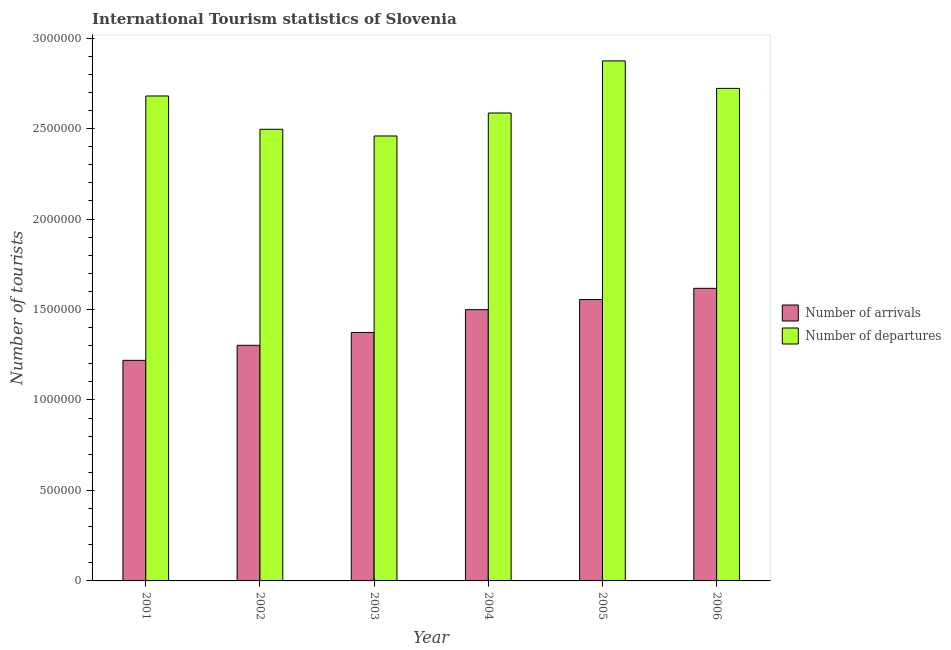How many groups of bars are there?
Provide a succinct answer. 6. Are the number of bars per tick equal to the number of legend labels?
Offer a very short reply. Yes. Are the number of bars on each tick of the X-axis equal?
Your answer should be very brief. Yes. How many bars are there on the 2nd tick from the left?
Give a very brief answer. 2. What is the number of tourist departures in 2001?
Provide a succinct answer. 2.68e+06. Across all years, what is the maximum number of tourist departures?
Your answer should be compact. 2.87e+06. Across all years, what is the minimum number of tourist departures?
Make the answer very short. 2.46e+06. What is the total number of tourist departures in the graph?
Provide a short and direct response. 1.58e+07. What is the difference between the number of tourist arrivals in 2001 and that in 2004?
Provide a succinct answer. -2.80e+05. What is the difference between the number of tourist arrivals in 2003 and the number of tourist departures in 2005?
Provide a short and direct response. -1.82e+05. What is the average number of tourist departures per year?
Your response must be concise. 2.64e+06. In how many years, is the number of tourist arrivals greater than 1400000?
Your response must be concise. 3. What is the ratio of the number of tourist arrivals in 2003 to that in 2005?
Give a very brief answer. 0.88. What is the difference between the highest and the second highest number of tourist arrivals?
Your answer should be very brief. 6.20e+04. What is the difference between the highest and the lowest number of tourist departures?
Ensure brevity in your answer.  4.15e+05. Is the sum of the number of tourist departures in 2003 and 2006 greater than the maximum number of tourist arrivals across all years?
Provide a succinct answer. Yes. What does the 1st bar from the left in 2006 represents?
Offer a very short reply. Number of arrivals. What does the 1st bar from the right in 2003 represents?
Provide a short and direct response. Number of departures. How many years are there in the graph?
Keep it short and to the point. 6. Are the values on the major ticks of Y-axis written in scientific E-notation?
Keep it short and to the point. No. Does the graph contain grids?
Give a very brief answer. No. How are the legend labels stacked?
Keep it short and to the point. Vertical. What is the title of the graph?
Your response must be concise. International Tourism statistics of Slovenia. What is the label or title of the X-axis?
Give a very brief answer. Year. What is the label or title of the Y-axis?
Keep it short and to the point. Number of tourists. What is the Number of tourists of Number of arrivals in 2001?
Give a very brief answer. 1.22e+06. What is the Number of tourists of Number of departures in 2001?
Provide a succinct answer. 2.68e+06. What is the Number of tourists of Number of arrivals in 2002?
Give a very brief answer. 1.30e+06. What is the Number of tourists in Number of departures in 2002?
Your answer should be very brief. 2.50e+06. What is the Number of tourists of Number of arrivals in 2003?
Ensure brevity in your answer.  1.37e+06. What is the Number of tourists of Number of departures in 2003?
Provide a short and direct response. 2.46e+06. What is the Number of tourists of Number of arrivals in 2004?
Provide a short and direct response. 1.50e+06. What is the Number of tourists in Number of departures in 2004?
Keep it short and to the point. 2.59e+06. What is the Number of tourists in Number of arrivals in 2005?
Offer a very short reply. 1.56e+06. What is the Number of tourists in Number of departures in 2005?
Your answer should be compact. 2.87e+06. What is the Number of tourists in Number of arrivals in 2006?
Ensure brevity in your answer.  1.62e+06. What is the Number of tourists of Number of departures in 2006?
Offer a terse response. 2.72e+06. Across all years, what is the maximum Number of tourists of Number of arrivals?
Your response must be concise. 1.62e+06. Across all years, what is the maximum Number of tourists of Number of departures?
Provide a short and direct response. 2.87e+06. Across all years, what is the minimum Number of tourists of Number of arrivals?
Offer a terse response. 1.22e+06. Across all years, what is the minimum Number of tourists in Number of departures?
Ensure brevity in your answer.  2.46e+06. What is the total Number of tourists in Number of arrivals in the graph?
Your response must be concise. 8.56e+06. What is the total Number of tourists in Number of departures in the graph?
Your response must be concise. 1.58e+07. What is the difference between the Number of tourists in Number of arrivals in 2001 and that in 2002?
Make the answer very short. -8.30e+04. What is the difference between the Number of tourists in Number of departures in 2001 and that in 2002?
Your answer should be compact. 1.84e+05. What is the difference between the Number of tourists in Number of arrivals in 2001 and that in 2003?
Ensure brevity in your answer.  -1.54e+05. What is the difference between the Number of tourists in Number of departures in 2001 and that in 2003?
Provide a succinct answer. 2.21e+05. What is the difference between the Number of tourists of Number of arrivals in 2001 and that in 2004?
Provide a succinct answer. -2.80e+05. What is the difference between the Number of tourists of Number of departures in 2001 and that in 2004?
Your answer should be compact. 9.40e+04. What is the difference between the Number of tourists in Number of arrivals in 2001 and that in 2005?
Offer a terse response. -3.36e+05. What is the difference between the Number of tourists in Number of departures in 2001 and that in 2005?
Offer a very short reply. -1.94e+05. What is the difference between the Number of tourists of Number of arrivals in 2001 and that in 2006?
Provide a succinct answer. -3.98e+05. What is the difference between the Number of tourists of Number of departures in 2001 and that in 2006?
Offer a terse response. -4.20e+04. What is the difference between the Number of tourists in Number of arrivals in 2002 and that in 2003?
Your answer should be compact. -7.10e+04. What is the difference between the Number of tourists of Number of departures in 2002 and that in 2003?
Give a very brief answer. 3.70e+04. What is the difference between the Number of tourists in Number of arrivals in 2002 and that in 2004?
Give a very brief answer. -1.97e+05. What is the difference between the Number of tourists in Number of departures in 2002 and that in 2004?
Your answer should be very brief. -9.00e+04. What is the difference between the Number of tourists in Number of arrivals in 2002 and that in 2005?
Your response must be concise. -2.53e+05. What is the difference between the Number of tourists of Number of departures in 2002 and that in 2005?
Keep it short and to the point. -3.78e+05. What is the difference between the Number of tourists in Number of arrivals in 2002 and that in 2006?
Offer a terse response. -3.15e+05. What is the difference between the Number of tourists of Number of departures in 2002 and that in 2006?
Offer a very short reply. -2.26e+05. What is the difference between the Number of tourists in Number of arrivals in 2003 and that in 2004?
Your answer should be very brief. -1.26e+05. What is the difference between the Number of tourists in Number of departures in 2003 and that in 2004?
Ensure brevity in your answer.  -1.27e+05. What is the difference between the Number of tourists in Number of arrivals in 2003 and that in 2005?
Make the answer very short. -1.82e+05. What is the difference between the Number of tourists of Number of departures in 2003 and that in 2005?
Provide a short and direct response. -4.15e+05. What is the difference between the Number of tourists in Number of arrivals in 2003 and that in 2006?
Your response must be concise. -2.44e+05. What is the difference between the Number of tourists of Number of departures in 2003 and that in 2006?
Ensure brevity in your answer.  -2.63e+05. What is the difference between the Number of tourists in Number of arrivals in 2004 and that in 2005?
Your answer should be compact. -5.60e+04. What is the difference between the Number of tourists in Number of departures in 2004 and that in 2005?
Your answer should be compact. -2.88e+05. What is the difference between the Number of tourists of Number of arrivals in 2004 and that in 2006?
Ensure brevity in your answer.  -1.18e+05. What is the difference between the Number of tourists of Number of departures in 2004 and that in 2006?
Ensure brevity in your answer.  -1.36e+05. What is the difference between the Number of tourists of Number of arrivals in 2005 and that in 2006?
Ensure brevity in your answer.  -6.20e+04. What is the difference between the Number of tourists in Number of departures in 2005 and that in 2006?
Give a very brief answer. 1.52e+05. What is the difference between the Number of tourists of Number of arrivals in 2001 and the Number of tourists of Number of departures in 2002?
Offer a terse response. -1.28e+06. What is the difference between the Number of tourists of Number of arrivals in 2001 and the Number of tourists of Number of departures in 2003?
Offer a terse response. -1.24e+06. What is the difference between the Number of tourists of Number of arrivals in 2001 and the Number of tourists of Number of departures in 2004?
Provide a succinct answer. -1.37e+06. What is the difference between the Number of tourists of Number of arrivals in 2001 and the Number of tourists of Number of departures in 2005?
Offer a terse response. -1.66e+06. What is the difference between the Number of tourists in Number of arrivals in 2001 and the Number of tourists in Number of departures in 2006?
Offer a very short reply. -1.50e+06. What is the difference between the Number of tourists in Number of arrivals in 2002 and the Number of tourists in Number of departures in 2003?
Keep it short and to the point. -1.16e+06. What is the difference between the Number of tourists of Number of arrivals in 2002 and the Number of tourists of Number of departures in 2004?
Your answer should be compact. -1.28e+06. What is the difference between the Number of tourists of Number of arrivals in 2002 and the Number of tourists of Number of departures in 2005?
Provide a succinct answer. -1.57e+06. What is the difference between the Number of tourists in Number of arrivals in 2002 and the Number of tourists in Number of departures in 2006?
Offer a terse response. -1.42e+06. What is the difference between the Number of tourists of Number of arrivals in 2003 and the Number of tourists of Number of departures in 2004?
Provide a short and direct response. -1.21e+06. What is the difference between the Number of tourists of Number of arrivals in 2003 and the Number of tourists of Number of departures in 2005?
Ensure brevity in your answer.  -1.50e+06. What is the difference between the Number of tourists of Number of arrivals in 2003 and the Number of tourists of Number of departures in 2006?
Your response must be concise. -1.35e+06. What is the difference between the Number of tourists in Number of arrivals in 2004 and the Number of tourists in Number of departures in 2005?
Make the answer very short. -1.38e+06. What is the difference between the Number of tourists of Number of arrivals in 2004 and the Number of tourists of Number of departures in 2006?
Your response must be concise. -1.22e+06. What is the difference between the Number of tourists of Number of arrivals in 2005 and the Number of tourists of Number of departures in 2006?
Offer a terse response. -1.17e+06. What is the average Number of tourists in Number of arrivals per year?
Keep it short and to the point. 1.43e+06. What is the average Number of tourists of Number of departures per year?
Offer a very short reply. 2.64e+06. In the year 2001, what is the difference between the Number of tourists in Number of arrivals and Number of tourists in Number of departures?
Your answer should be very brief. -1.46e+06. In the year 2002, what is the difference between the Number of tourists of Number of arrivals and Number of tourists of Number of departures?
Your response must be concise. -1.19e+06. In the year 2003, what is the difference between the Number of tourists in Number of arrivals and Number of tourists in Number of departures?
Your response must be concise. -1.09e+06. In the year 2004, what is the difference between the Number of tourists in Number of arrivals and Number of tourists in Number of departures?
Your answer should be very brief. -1.09e+06. In the year 2005, what is the difference between the Number of tourists of Number of arrivals and Number of tourists of Number of departures?
Provide a succinct answer. -1.32e+06. In the year 2006, what is the difference between the Number of tourists in Number of arrivals and Number of tourists in Number of departures?
Offer a terse response. -1.10e+06. What is the ratio of the Number of tourists in Number of arrivals in 2001 to that in 2002?
Your answer should be compact. 0.94. What is the ratio of the Number of tourists in Number of departures in 2001 to that in 2002?
Offer a very short reply. 1.07. What is the ratio of the Number of tourists of Number of arrivals in 2001 to that in 2003?
Your answer should be very brief. 0.89. What is the ratio of the Number of tourists in Number of departures in 2001 to that in 2003?
Offer a terse response. 1.09. What is the ratio of the Number of tourists in Number of arrivals in 2001 to that in 2004?
Your response must be concise. 0.81. What is the ratio of the Number of tourists in Number of departures in 2001 to that in 2004?
Give a very brief answer. 1.04. What is the ratio of the Number of tourists of Number of arrivals in 2001 to that in 2005?
Provide a succinct answer. 0.78. What is the ratio of the Number of tourists in Number of departures in 2001 to that in 2005?
Provide a succinct answer. 0.93. What is the ratio of the Number of tourists in Number of arrivals in 2001 to that in 2006?
Your response must be concise. 0.75. What is the ratio of the Number of tourists in Number of departures in 2001 to that in 2006?
Provide a succinct answer. 0.98. What is the ratio of the Number of tourists of Number of arrivals in 2002 to that in 2003?
Give a very brief answer. 0.95. What is the ratio of the Number of tourists in Number of departures in 2002 to that in 2003?
Provide a succinct answer. 1.01. What is the ratio of the Number of tourists in Number of arrivals in 2002 to that in 2004?
Provide a succinct answer. 0.87. What is the ratio of the Number of tourists of Number of departures in 2002 to that in 2004?
Provide a short and direct response. 0.97. What is the ratio of the Number of tourists of Number of arrivals in 2002 to that in 2005?
Make the answer very short. 0.84. What is the ratio of the Number of tourists of Number of departures in 2002 to that in 2005?
Your response must be concise. 0.87. What is the ratio of the Number of tourists of Number of arrivals in 2002 to that in 2006?
Provide a succinct answer. 0.81. What is the ratio of the Number of tourists of Number of departures in 2002 to that in 2006?
Provide a short and direct response. 0.92. What is the ratio of the Number of tourists in Number of arrivals in 2003 to that in 2004?
Your answer should be compact. 0.92. What is the ratio of the Number of tourists in Number of departures in 2003 to that in 2004?
Your answer should be compact. 0.95. What is the ratio of the Number of tourists in Number of arrivals in 2003 to that in 2005?
Provide a short and direct response. 0.88. What is the ratio of the Number of tourists of Number of departures in 2003 to that in 2005?
Offer a terse response. 0.86. What is the ratio of the Number of tourists in Number of arrivals in 2003 to that in 2006?
Provide a short and direct response. 0.85. What is the ratio of the Number of tourists in Number of departures in 2003 to that in 2006?
Provide a succinct answer. 0.9. What is the ratio of the Number of tourists of Number of departures in 2004 to that in 2005?
Your response must be concise. 0.9. What is the ratio of the Number of tourists in Number of arrivals in 2004 to that in 2006?
Your answer should be very brief. 0.93. What is the ratio of the Number of tourists in Number of departures in 2004 to that in 2006?
Offer a very short reply. 0.95. What is the ratio of the Number of tourists in Number of arrivals in 2005 to that in 2006?
Your answer should be compact. 0.96. What is the ratio of the Number of tourists in Number of departures in 2005 to that in 2006?
Provide a short and direct response. 1.06. What is the difference between the highest and the second highest Number of tourists of Number of arrivals?
Provide a succinct answer. 6.20e+04. What is the difference between the highest and the second highest Number of tourists in Number of departures?
Your answer should be compact. 1.52e+05. What is the difference between the highest and the lowest Number of tourists of Number of arrivals?
Offer a terse response. 3.98e+05. What is the difference between the highest and the lowest Number of tourists in Number of departures?
Offer a very short reply. 4.15e+05. 